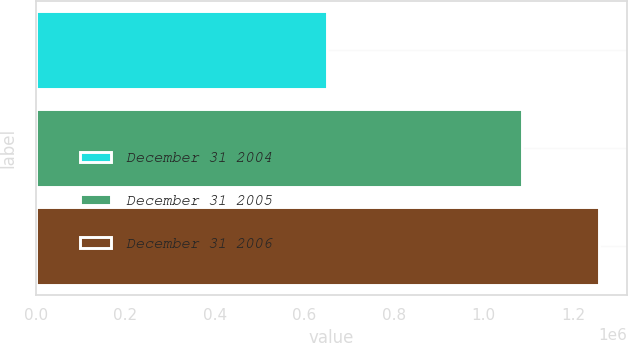<chart> <loc_0><loc_0><loc_500><loc_500><bar_chart><fcel>December 31 2004<fcel>December 31 2005<fcel>December 31 2006<nl><fcel>649240<fcel>1.08584e+06<fcel>1.25676e+06<nl></chart> 